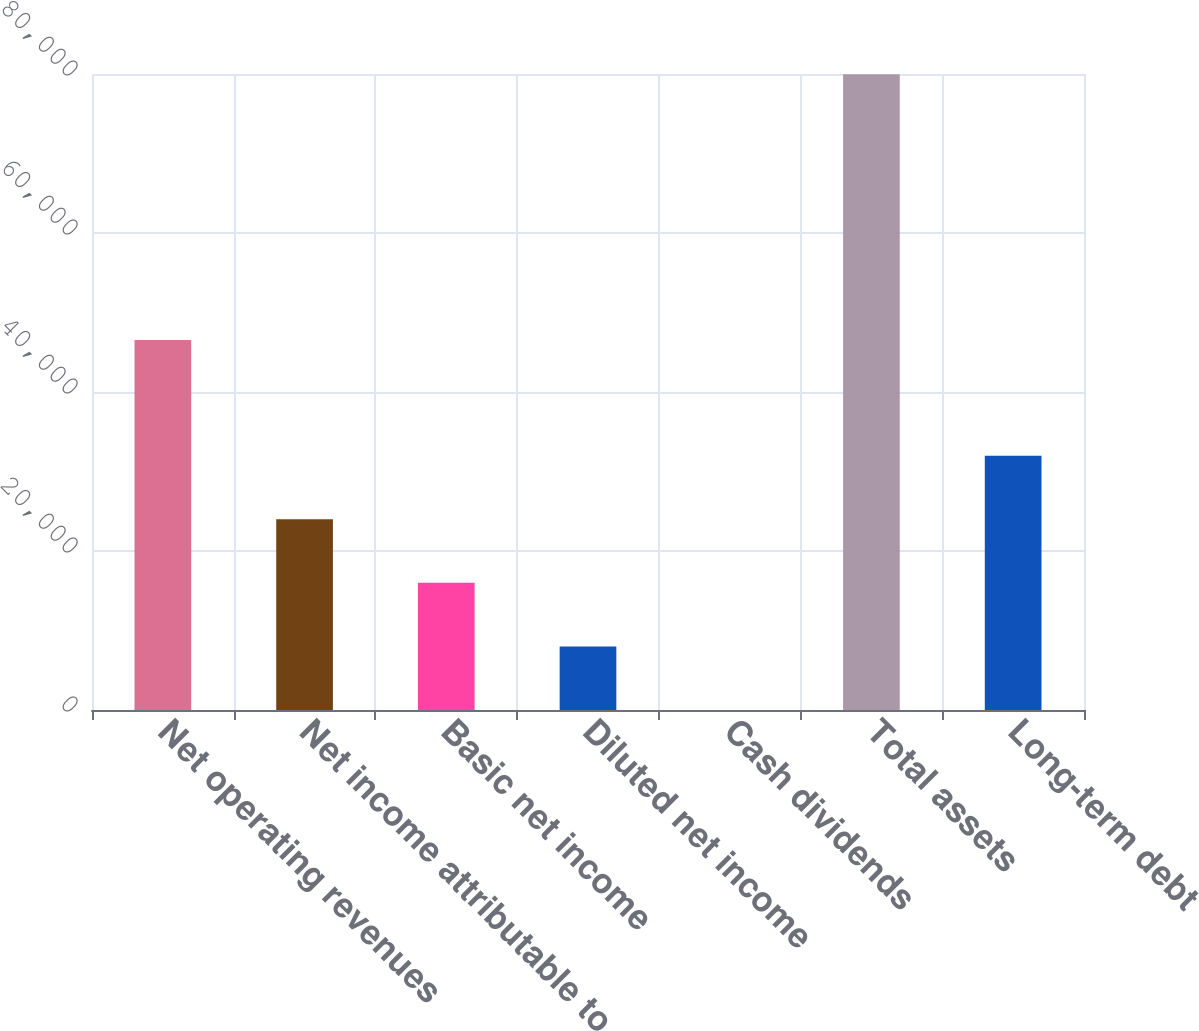Convert chart to OTSL. <chart><loc_0><loc_0><loc_500><loc_500><bar_chart><fcel>Net operating revenues<fcel>Net income attributable to<fcel>Basic net income<fcel>Diluted net income<fcel>Cash dividends<fcel>Total assets<fcel>Long-term debt<nl><fcel>46542<fcel>23992.9<fcel>15995.6<fcel>7998.25<fcel>0.94<fcel>79974<fcel>31990.2<nl></chart> 